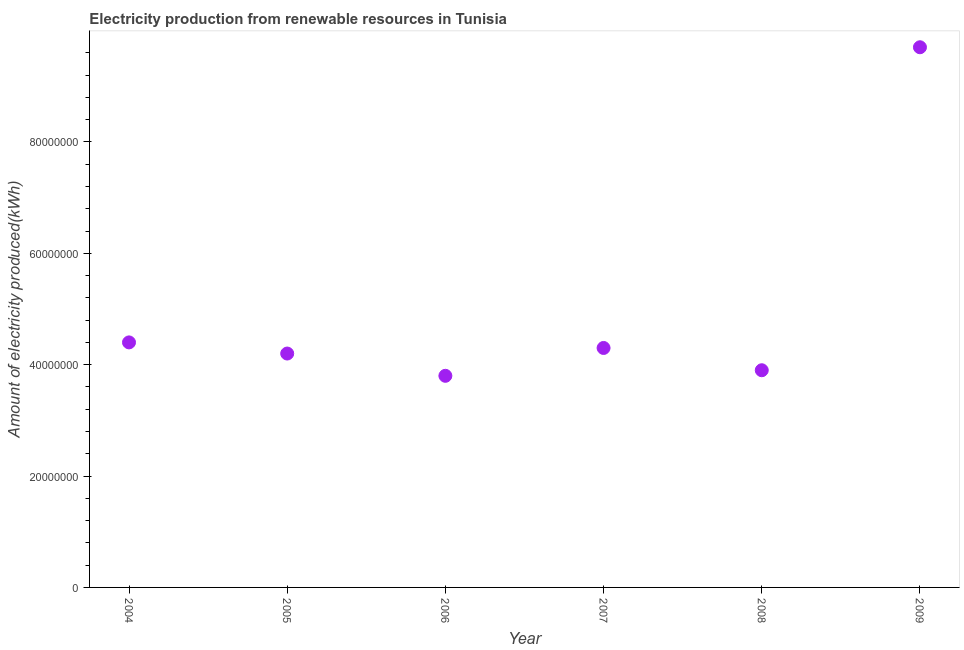What is the amount of electricity produced in 2006?
Provide a short and direct response. 3.80e+07. Across all years, what is the maximum amount of electricity produced?
Offer a very short reply. 9.70e+07. Across all years, what is the minimum amount of electricity produced?
Offer a very short reply. 3.80e+07. What is the sum of the amount of electricity produced?
Your answer should be very brief. 3.03e+08. What is the difference between the amount of electricity produced in 2008 and 2009?
Your answer should be compact. -5.80e+07. What is the average amount of electricity produced per year?
Ensure brevity in your answer.  5.05e+07. What is the median amount of electricity produced?
Offer a very short reply. 4.25e+07. In how many years, is the amount of electricity produced greater than 36000000 kWh?
Your answer should be compact. 6. What is the ratio of the amount of electricity produced in 2006 to that in 2007?
Provide a short and direct response. 0.88. Is the difference between the amount of electricity produced in 2006 and 2007 greater than the difference between any two years?
Ensure brevity in your answer.  No. What is the difference between the highest and the second highest amount of electricity produced?
Offer a very short reply. 5.30e+07. What is the difference between the highest and the lowest amount of electricity produced?
Ensure brevity in your answer.  5.90e+07. What is the difference between two consecutive major ticks on the Y-axis?
Your answer should be very brief. 2.00e+07. Are the values on the major ticks of Y-axis written in scientific E-notation?
Ensure brevity in your answer.  No. Does the graph contain any zero values?
Offer a very short reply. No. What is the title of the graph?
Give a very brief answer. Electricity production from renewable resources in Tunisia. What is the label or title of the Y-axis?
Make the answer very short. Amount of electricity produced(kWh). What is the Amount of electricity produced(kWh) in 2004?
Your answer should be compact. 4.40e+07. What is the Amount of electricity produced(kWh) in 2005?
Provide a short and direct response. 4.20e+07. What is the Amount of electricity produced(kWh) in 2006?
Your response must be concise. 3.80e+07. What is the Amount of electricity produced(kWh) in 2007?
Keep it short and to the point. 4.30e+07. What is the Amount of electricity produced(kWh) in 2008?
Offer a very short reply. 3.90e+07. What is the Amount of electricity produced(kWh) in 2009?
Your response must be concise. 9.70e+07. What is the difference between the Amount of electricity produced(kWh) in 2004 and 2007?
Give a very brief answer. 1.00e+06. What is the difference between the Amount of electricity produced(kWh) in 2004 and 2008?
Your answer should be compact. 5.00e+06. What is the difference between the Amount of electricity produced(kWh) in 2004 and 2009?
Make the answer very short. -5.30e+07. What is the difference between the Amount of electricity produced(kWh) in 2005 and 2006?
Your response must be concise. 4.00e+06. What is the difference between the Amount of electricity produced(kWh) in 2005 and 2007?
Your response must be concise. -1.00e+06. What is the difference between the Amount of electricity produced(kWh) in 2005 and 2008?
Give a very brief answer. 3.00e+06. What is the difference between the Amount of electricity produced(kWh) in 2005 and 2009?
Keep it short and to the point. -5.50e+07. What is the difference between the Amount of electricity produced(kWh) in 2006 and 2007?
Keep it short and to the point. -5.00e+06. What is the difference between the Amount of electricity produced(kWh) in 2006 and 2008?
Provide a short and direct response. -1.00e+06. What is the difference between the Amount of electricity produced(kWh) in 2006 and 2009?
Your response must be concise. -5.90e+07. What is the difference between the Amount of electricity produced(kWh) in 2007 and 2008?
Give a very brief answer. 4.00e+06. What is the difference between the Amount of electricity produced(kWh) in 2007 and 2009?
Offer a very short reply. -5.40e+07. What is the difference between the Amount of electricity produced(kWh) in 2008 and 2009?
Offer a very short reply. -5.80e+07. What is the ratio of the Amount of electricity produced(kWh) in 2004 to that in 2005?
Ensure brevity in your answer.  1.05. What is the ratio of the Amount of electricity produced(kWh) in 2004 to that in 2006?
Make the answer very short. 1.16. What is the ratio of the Amount of electricity produced(kWh) in 2004 to that in 2007?
Ensure brevity in your answer.  1.02. What is the ratio of the Amount of electricity produced(kWh) in 2004 to that in 2008?
Provide a short and direct response. 1.13. What is the ratio of the Amount of electricity produced(kWh) in 2004 to that in 2009?
Provide a short and direct response. 0.45. What is the ratio of the Amount of electricity produced(kWh) in 2005 to that in 2006?
Keep it short and to the point. 1.1. What is the ratio of the Amount of electricity produced(kWh) in 2005 to that in 2007?
Provide a succinct answer. 0.98. What is the ratio of the Amount of electricity produced(kWh) in 2005 to that in 2008?
Provide a short and direct response. 1.08. What is the ratio of the Amount of electricity produced(kWh) in 2005 to that in 2009?
Provide a short and direct response. 0.43. What is the ratio of the Amount of electricity produced(kWh) in 2006 to that in 2007?
Your answer should be very brief. 0.88. What is the ratio of the Amount of electricity produced(kWh) in 2006 to that in 2009?
Provide a succinct answer. 0.39. What is the ratio of the Amount of electricity produced(kWh) in 2007 to that in 2008?
Provide a succinct answer. 1.1. What is the ratio of the Amount of electricity produced(kWh) in 2007 to that in 2009?
Your answer should be very brief. 0.44. What is the ratio of the Amount of electricity produced(kWh) in 2008 to that in 2009?
Offer a very short reply. 0.4. 